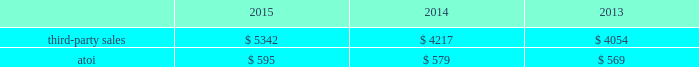Engineered products and solutions .
This segment represents a portion of alcoa 2019s downstream operations and produces products that are used mostly in the aerospace ( commercial and defense ) , commercial transportation , and power generation end markets .
Such products include fastening systems ( titanium , steel , and nickel alloys ) and seamless rolled rings ( mostly nickel alloys ) ; and investment castings ( nickel super alloys , titanium , and aluminum ) , including airfoils and forged jet engine components ( e.g. , jet engine disks ) , all of which are sold directly to customers and through distributors .
More than 70% ( 70 % ) of the third- party sales in this segment are from the aerospace end market .
A small part of this segment also produces various forging and extrusion metal products for the oil and gas , industrial products , automotive , and land and sea defense end markets .
Seasonal decreases in sales are generally experienced in the third quarter of the year due to the european summer slowdown across all end markets .
Generally , the sales and costs and expenses of this segment are transacted in the local currency of the respective operations , which are mostly the u.s .
Dollar and the euro .
In march 2015 , alcoa completed the acquisition of an aerospace castings company , tital , a privately held company with approximately 650 employees based in germany .
Tital produces aluminum and titanium investment casting products for the aerospace and defense end markets .
In 2014 , tital generated sales of approximately $ 100 .
The purpose of this acquisition is to capture increasing demand for advanced jet engine components made of titanium , establish titanium-casting capabilities in europe , and expand existing aluminum casting capacity .
The operating results and assets and liabilities of tital were included within the engineered products and solutions segment since the date of acquisition .
Also in march 2015 , alcoa signed a definitive agreement to acquire rti international metals , inc .
( rti ) , a global supplier of titanium and specialty metal products and services for the commercial aerospace , defense , energy , and medical device end markets .
On july 23 , 2015 , after satisfying all customary closing conditions and receiving the required regulatory and rti shareholder approvals , alcoa completed the acquisition of rti .
The purpose of this acquisition is to expand alcoa 2019s range of titanium offerings and add advanced technologies and materials , primarily related to the aerospace end market .
In 2014 , rti generated net sales of $ 794 and had approximately 2600 employees .
Alcoa estimates that rti will generate approximately $ 1200 in third-party sales by 2019 .
In executing its integration plan for rti , alcoa expects to realize annual cost savings of approximately $ 100 by 2019 due to synergies derived from procurement and productivity improvements , leveraging alcoa 2019s global shared services , and driving profitable growth .
The operating results and assets and liabilities of rti were included within the engineered products and solutions segment since the date of acquisition .
On november 19 , 2014 , after satisfying all customary closing conditions and receiving the required regulatory approvals , alcoa completed the acquisition of firth rixson , a global leader in aerospace jet engine components .
Firth rixson manufactures rings , forgings , and metal products for the aerospace end market , as well as other markets requiring highly engineered material applications .
The purpose of this acquisition is to strengthen alcoa 2019s aerospace business and position the company to capture additional aerospace growth with a broader range of high-growth , value- add jet engine components .
This business generated sales of approximately $ 970 in 2014 and has 13 operating facilities in the united states , united kingdom , europe , and asia employing approximately 2400 people combined .
In executing its integration plan for firth rixson , alcoa expects to realize annual cost savings of more than $ 100 by 2019 due to synergies derived from procurement and productivity improvements , optimizing internal metal supply , and leveraging alcoa 2019s global shared services .
The operating results and assets and liabilities of firth rixson were included within the engineered products and solutions segment since the date of acquisition .
Third-party sales for the engineered products and solutions segment improved 27% ( 27 % ) in 2015 compared with 2014 , largely attributable to the third-party sales ( $ 1310 ) of three acquired businesses ( see above ) , primarily aerospace- related , and higher volumes in this segment 2019s organic businesses , mostly related to the aerospace end market .
These positive impacts were slightly offset by unfavorable foreign currency movements , principally driven by a weaker euro. .
What is the total of dollars brought in by the aerospace end market segment in 2015? 
Rationale: it is the total sales value of the third party sales multiplied by the percentage of the aerospace end market segment sales ( 70% ) .
Computations: (70% * 5342)
Answer: 3739.4. 